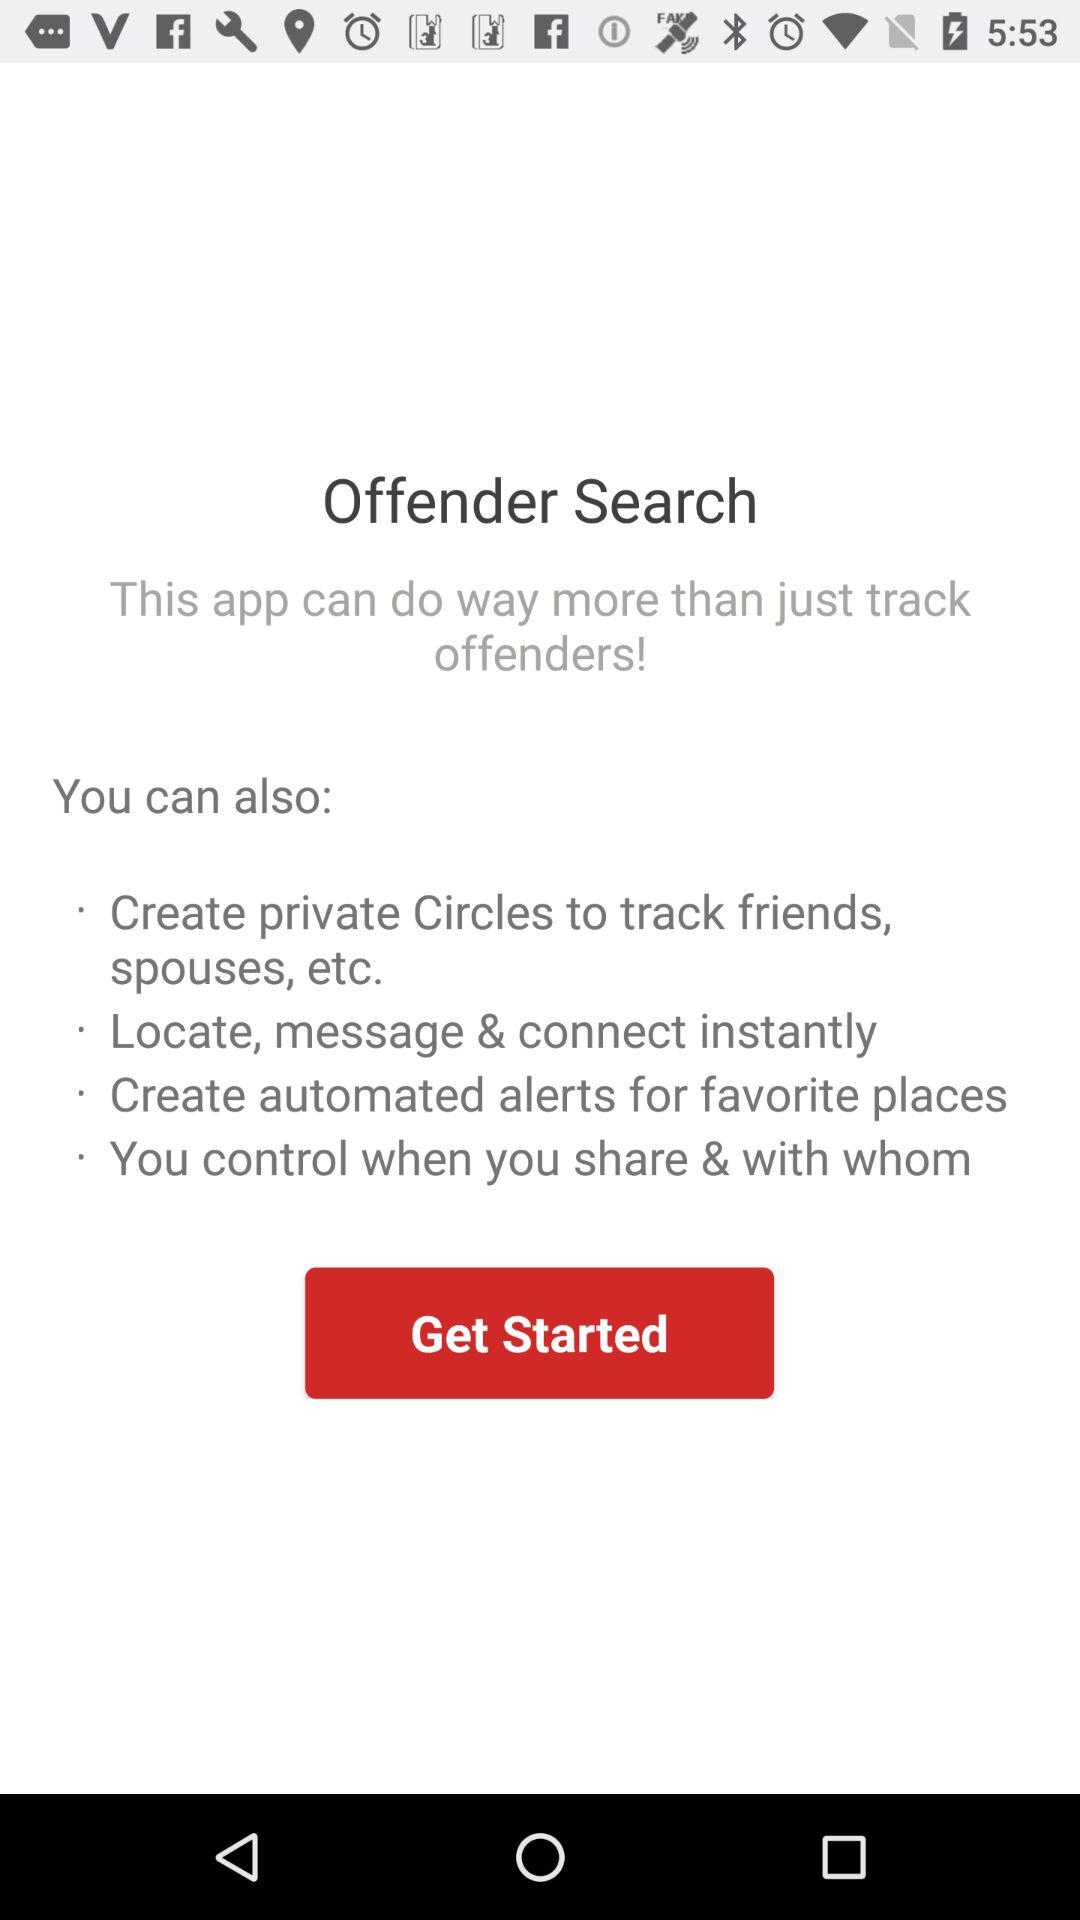What is the application name? The application name is "Offender Search". 